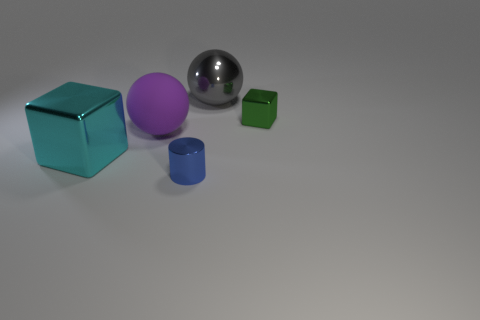Add 4 large cyan blocks. How many objects exist? 9 Subtract all spheres. How many objects are left? 3 Subtract all gray metallic things. Subtract all big gray balls. How many objects are left? 3 Add 4 small metallic cubes. How many small metallic cubes are left? 5 Add 4 large cyan things. How many large cyan things exist? 5 Subtract 0 gray cylinders. How many objects are left? 5 